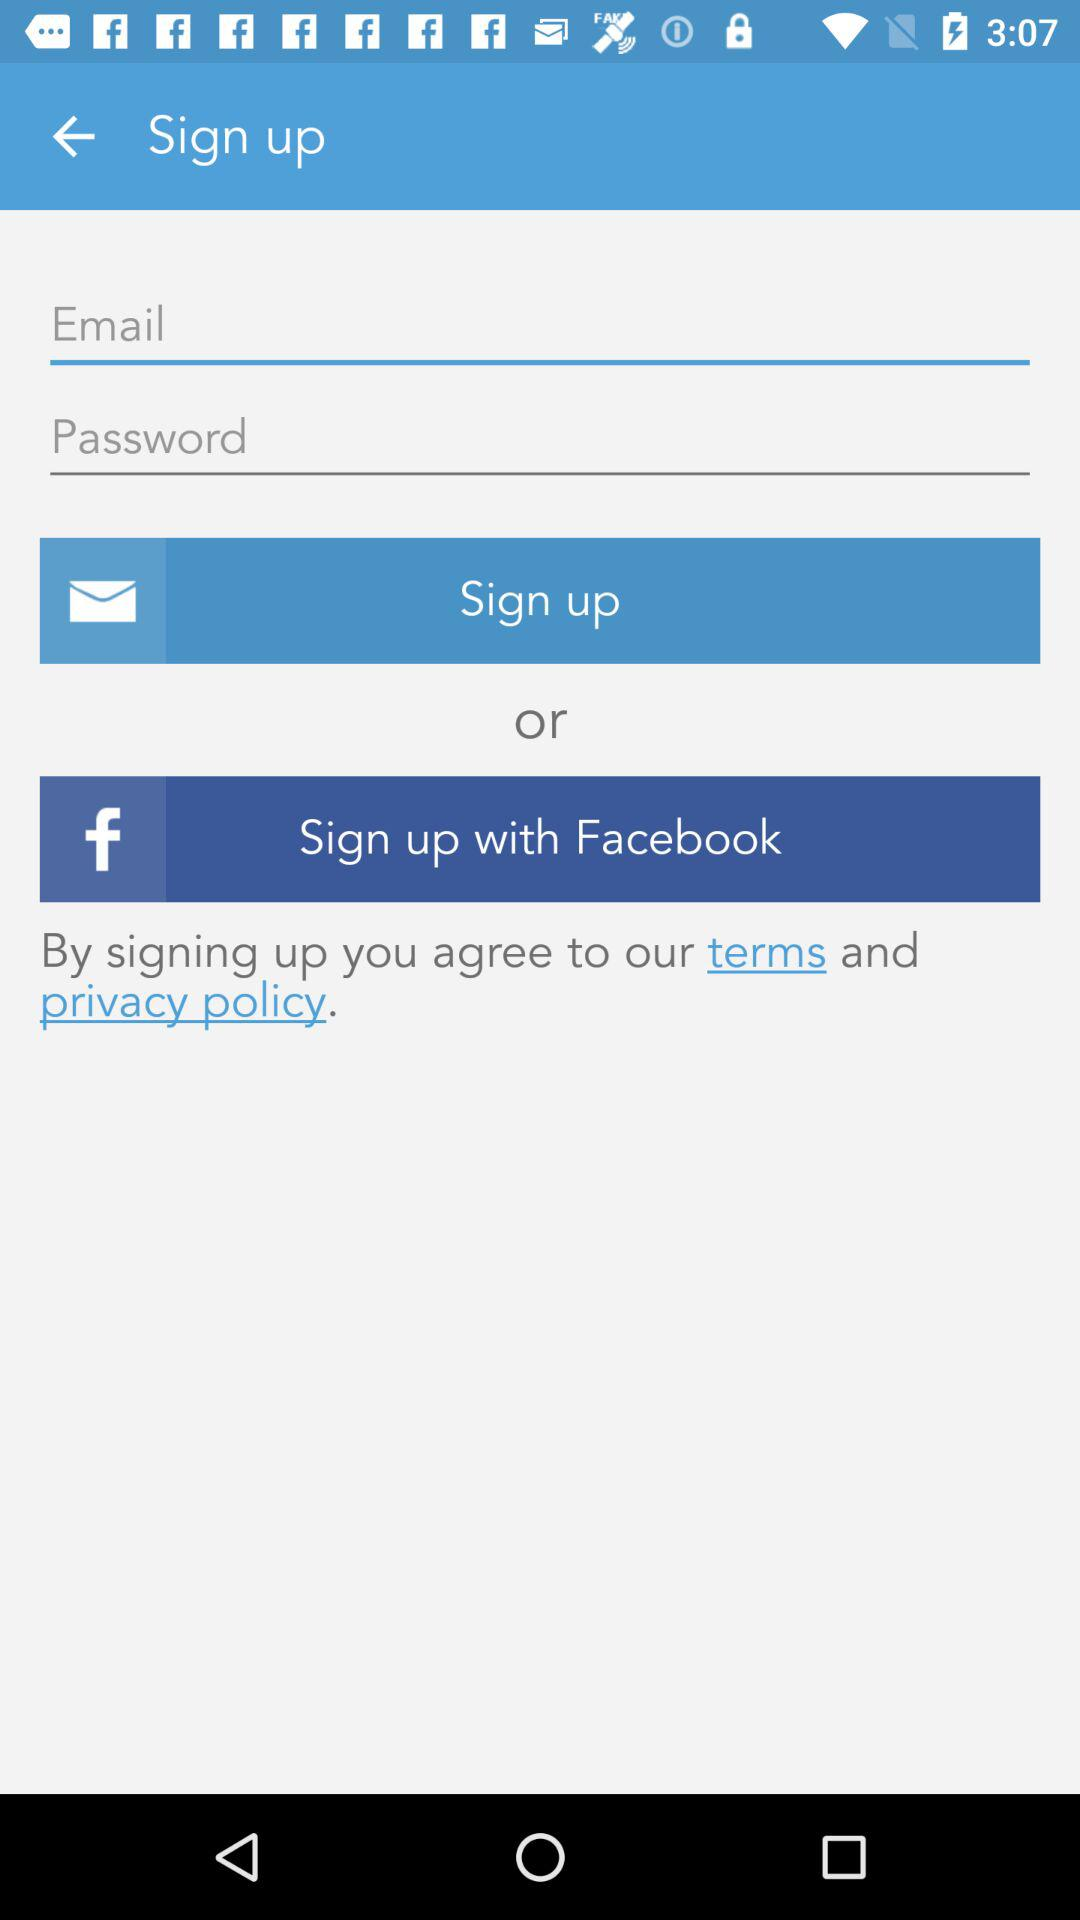Which options are given for signing up? The options that are given for signing up are "Email" and "Facebook". 